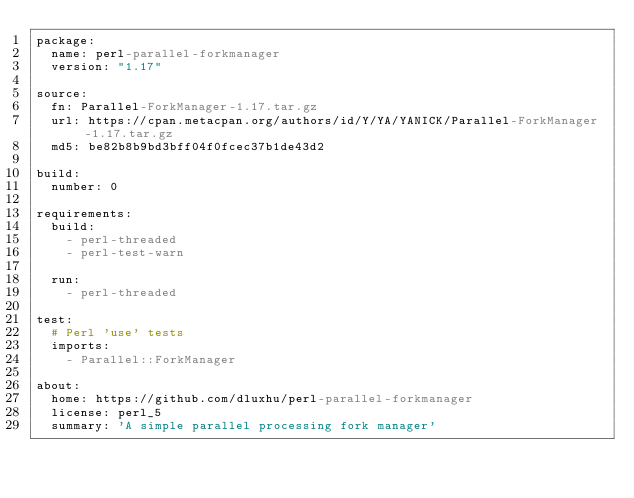Convert code to text. <code><loc_0><loc_0><loc_500><loc_500><_YAML_>package:
  name: perl-parallel-forkmanager
  version: "1.17"

source:
  fn: Parallel-ForkManager-1.17.tar.gz
  url: https://cpan.metacpan.org/authors/id/Y/YA/YANICK/Parallel-ForkManager-1.17.tar.gz
  md5: be82b8b9bd3bff04f0fcec37b1de43d2

build:
  number: 0

requirements:
  build:
    - perl-threaded
    - perl-test-warn

  run:
    - perl-threaded

test:
  # Perl 'use' tests
  imports:
    - Parallel::ForkManager

about:
  home: https://github.com/dluxhu/perl-parallel-forkmanager
  license: perl_5
  summary: 'A simple parallel processing fork manager'
</code> 